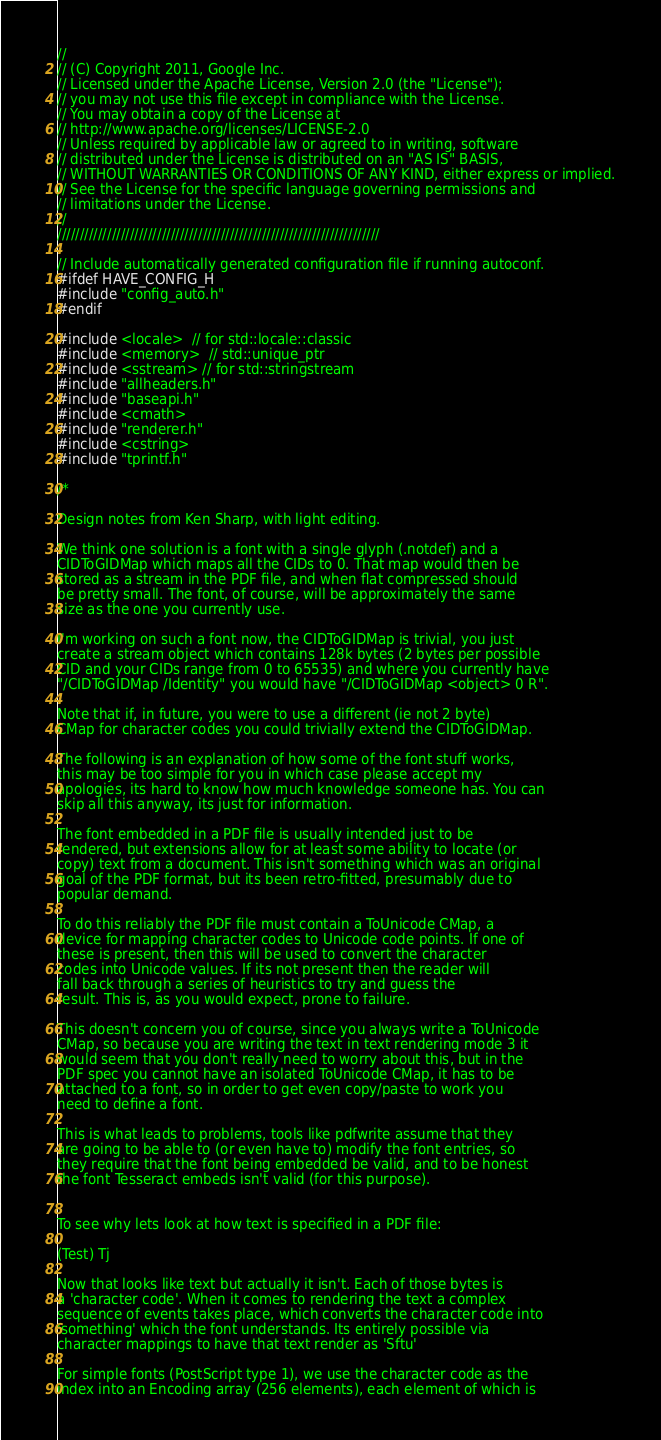<code> <loc_0><loc_0><loc_500><loc_500><_C++_>//
// (C) Copyright 2011, Google Inc.
// Licensed under the Apache License, Version 2.0 (the "License");
// you may not use this file except in compliance with the License.
// You may obtain a copy of the License at
// http://www.apache.org/licenses/LICENSE-2.0
// Unless required by applicable law or agreed to in writing, software
// distributed under the License is distributed on an "AS IS" BASIS,
// WITHOUT WARRANTIES OR CONDITIONS OF ANY KIND, either express or implied.
// See the License for the specific language governing permissions and
// limitations under the License.
//
///////////////////////////////////////////////////////////////////////

// Include automatically generated configuration file if running autoconf.
#ifdef HAVE_CONFIG_H
#include "config_auto.h"
#endif

#include <locale>  // for std::locale::classic
#include <memory>  // std::unique_ptr
#include <sstream> // for std::stringstream
#include "allheaders.h"
#include "baseapi.h"
#include <cmath>
#include "renderer.h"
#include <cstring>
#include "tprintf.h"

/*

Design notes from Ken Sharp, with light editing.

We think one solution is a font with a single glyph (.notdef) and a
CIDToGIDMap which maps all the CIDs to 0. That map would then be
stored as a stream in the PDF file, and when flat compressed should
be pretty small. The font, of course, will be approximately the same
size as the one you currently use.

I'm working on such a font now, the CIDToGIDMap is trivial, you just
create a stream object which contains 128k bytes (2 bytes per possible
CID and your CIDs range from 0 to 65535) and where you currently have
"/CIDToGIDMap /Identity" you would have "/CIDToGIDMap <object> 0 R".

Note that if, in future, you were to use a different (ie not 2 byte)
CMap for character codes you could trivially extend the CIDToGIDMap.

The following is an explanation of how some of the font stuff works,
this may be too simple for you in which case please accept my
apologies, its hard to know how much knowledge someone has. You can
skip all this anyway, its just for information.

The font embedded in a PDF file is usually intended just to be
rendered, but extensions allow for at least some ability to locate (or
copy) text from a document. This isn't something which was an original
goal of the PDF format, but its been retro-fitted, presumably due to
popular demand.

To do this reliably the PDF file must contain a ToUnicode CMap, a
device for mapping character codes to Unicode code points. If one of
these is present, then this will be used to convert the character
codes into Unicode values. If its not present then the reader will
fall back through a series of heuristics to try and guess the
result. This is, as you would expect, prone to failure.

This doesn't concern you of course, since you always write a ToUnicode
CMap, so because you are writing the text in text rendering mode 3 it
would seem that you don't really need to worry about this, but in the
PDF spec you cannot have an isolated ToUnicode CMap, it has to be
attached to a font, so in order to get even copy/paste to work you
need to define a font.

This is what leads to problems, tools like pdfwrite assume that they
are going to be able to (or even have to) modify the font entries, so
they require that the font being embedded be valid, and to be honest
the font Tesseract embeds isn't valid (for this purpose).


To see why lets look at how text is specified in a PDF file:

(Test) Tj

Now that looks like text but actually it isn't. Each of those bytes is
a 'character code'. When it comes to rendering the text a complex
sequence of events takes place, which converts the character code into
'something' which the font understands. Its entirely possible via
character mappings to have that text render as 'Sftu'

For simple fonts (PostScript type 1), we use the character code as the
index into an Encoding array (256 elements), each element of which is</code> 